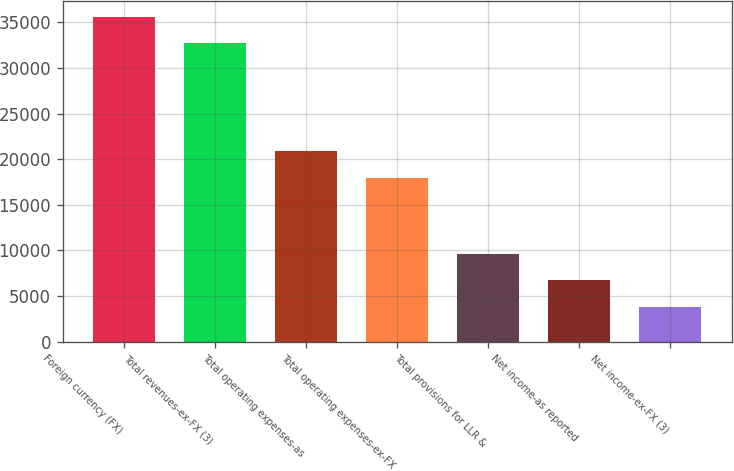Convert chart to OTSL. <chart><loc_0><loc_0><loc_500><loc_500><bar_chart><fcel>Foreign currency (FX)<fcel>Total revenues-ex-FX (3)<fcel>Total operating expenses-as<fcel>Total operating expenses-ex-FX<fcel>Total provisions for LLR &<fcel>Net income-as reported<fcel>Net income-ex-FX (3)<nl><fcel>35605.7<fcel>32706<fcel>20848.7<fcel>17949<fcel>9640.4<fcel>6740.7<fcel>3841<nl></chart> 